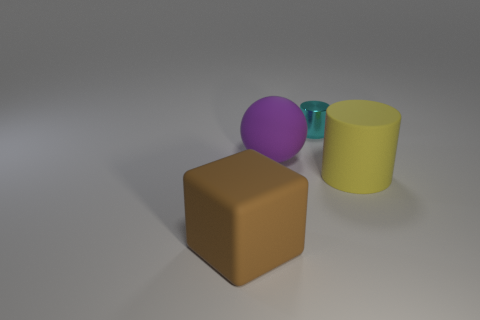Are there any other things that are made of the same material as the cyan object?
Keep it short and to the point. No. Are there any other tiny brown things of the same shape as the shiny thing?
Make the answer very short. No. There is a large thing on the right side of the small thing; what shape is it?
Keep it short and to the point. Cylinder. What number of rubber blocks are there?
Offer a very short reply. 1. What color is the cylinder that is made of the same material as the big brown thing?
Your response must be concise. Yellow. What number of tiny objects are either cyan cylinders or yellow cylinders?
Your response must be concise. 1. How many large rubber things are in front of the matte ball?
Your answer should be compact. 2. There is another large object that is the same shape as the cyan shiny object; what color is it?
Provide a short and direct response. Yellow. What number of metallic objects are either large blue cylinders or cylinders?
Offer a terse response. 1. There is a big yellow matte thing that is on the right side of the rubber sphere left of the large cylinder; are there any big yellow objects that are on the left side of it?
Your answer should be very brief. No. 